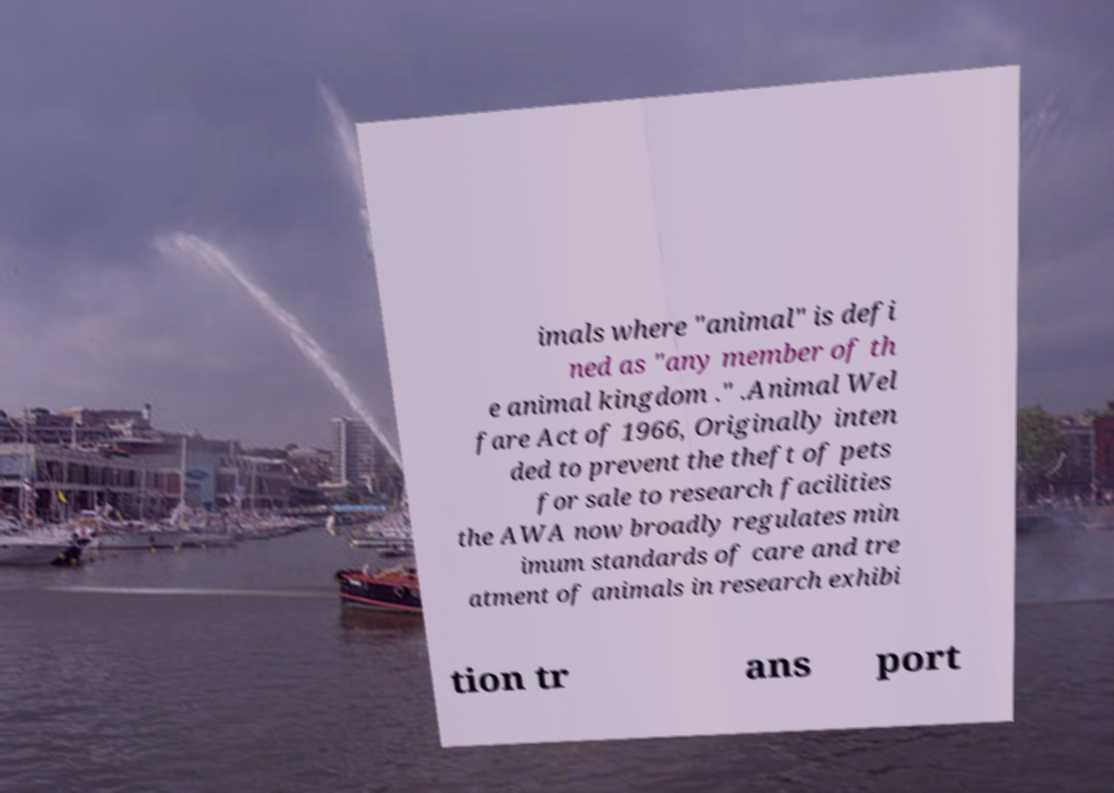Could you extract and type out the text from this image? imals where "animal" is defi ned as "any member of th e animal kingdom ." .Animal Wel fare Act of 1966, Originally inten ded to prevent the theft of pets for sale to research facilities the AWA now broadly regulates min imum standards of care and tre atment of animals in research exhibi tion tr ans port 